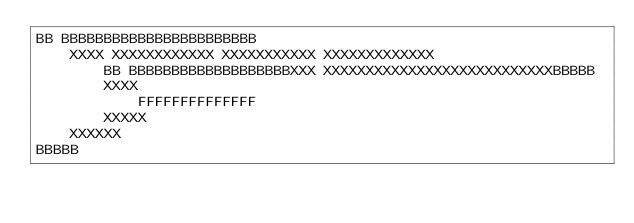Convert code to text. <code><loc_0><loc_0><loc_500><loc_500><_Python_>BB BBBBBBBBBBBBBBBBBBBBBBB
    XXXX XXXXXXXXXXXX XXXXXXXXXXX XXXXXXXXXXXXX
        BB BBBBBBBBBBBBBBBBBBBXXX XXXXXXXXXXXXXXXXXXXXXXXXXXXBBBBB
        XXXX
            FFFFFFFFFFFFFF
        XXXXX
    XXXXXX
BBBBB

</code> 